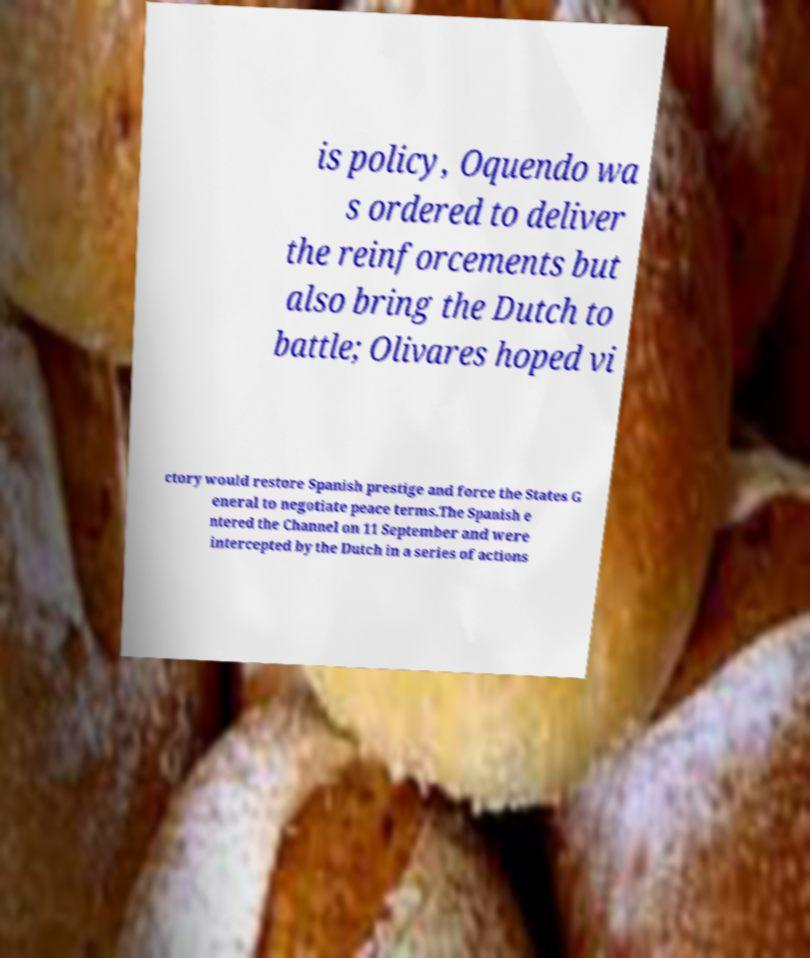Can you read and provide the text displayed in the image?This photo seems to have some interesting text. Can you extract and type it out for me? is policy, Oquendo wa s ordered to deliver the reinforcements but also bring the Dutch to battle; Olivares hoped vi ctory would restore Spanish prestige and force the States G eneral to negotiate peace terms.The Spanish e ntered the Channel on 11 September and were intercepted by the Dutch in a series of actions 